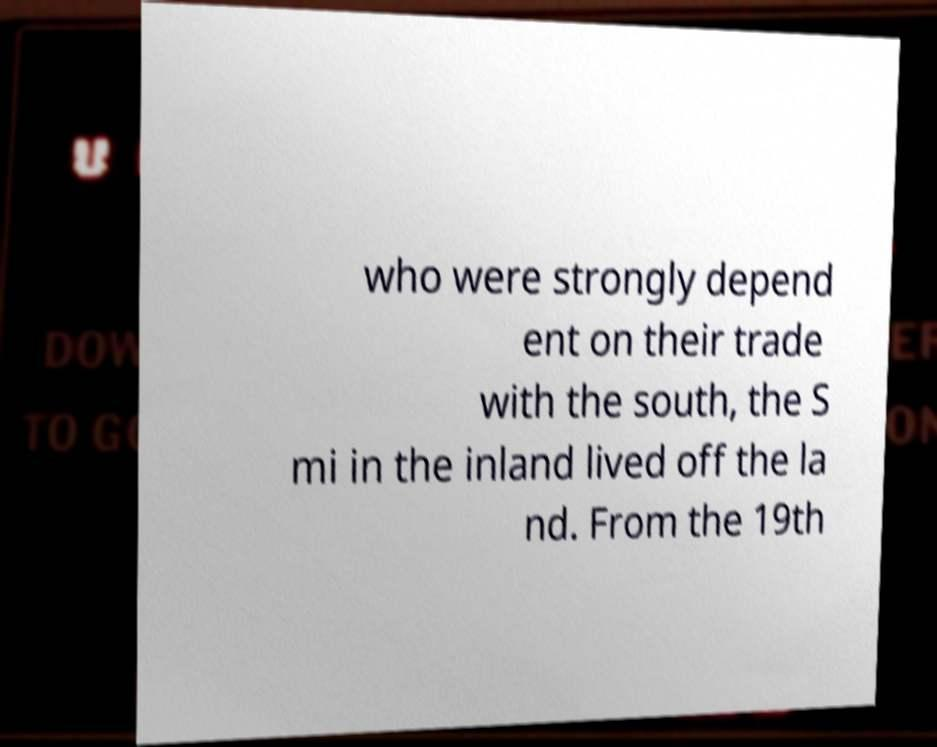What messages or text are displayed in this image? I need them in a readable, typed format. who were strongly depend ent on their trade with the south, the S mi in the inland lived off the la nd. From the 19th 